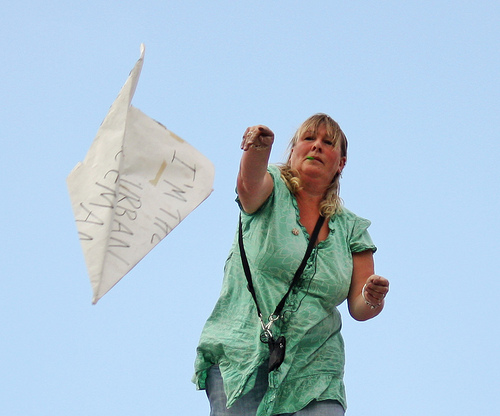<image>
Can you confirm if the woman is under the paper airplane? No. The woman is not positioned under the paper airplane. The vertical relationship between these objects is different. 